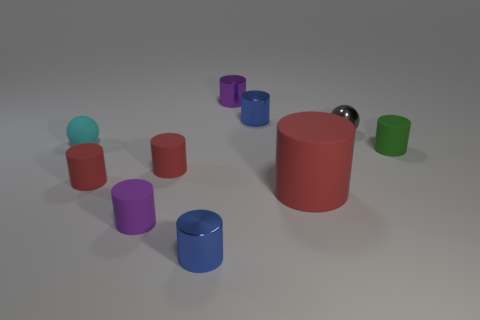Subtract all green spheres. How many red cylinders are left? 3 Subtract all red cylinders. How many cylinders are left? 5 Subtract 5 cylinders. How many cylinders are left? 3 Subtract all tiny green matte cylinders. How many cylinders are left? 7 Subtract all cyan cylinders. Subtract all brown blocks. How many cylinders are left? 8 Subtract all spheres. How many objects are left? 8 Subtract all green things. Subtract all tiny matte cylinders. How many objects are left? 5 Add 7 green rubber cylinders. How many green rubber cylinders are left? 8 Add 8 tiny gray spheres. How many tiny gray spheres exist? 9 Subtract 0 purple cubes. How many objects are left? 10 